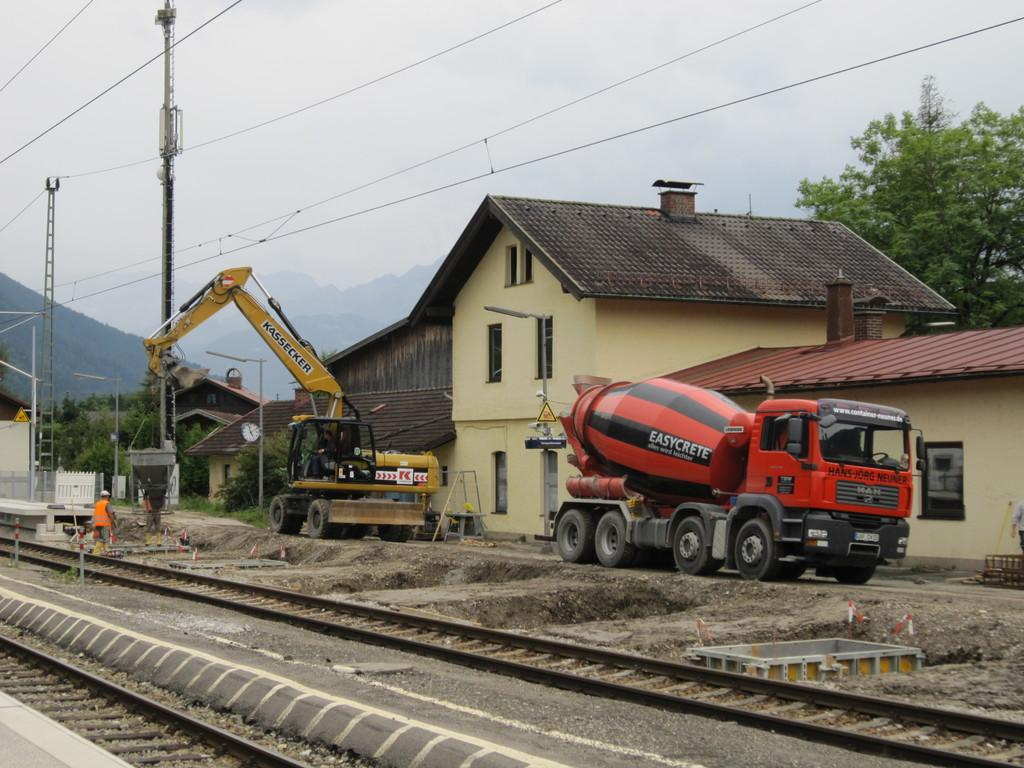<image>
Offer a succinct explanation of the picture presented. A black and orange colored cement mixer bears the simplistic brand name Easycrete. 